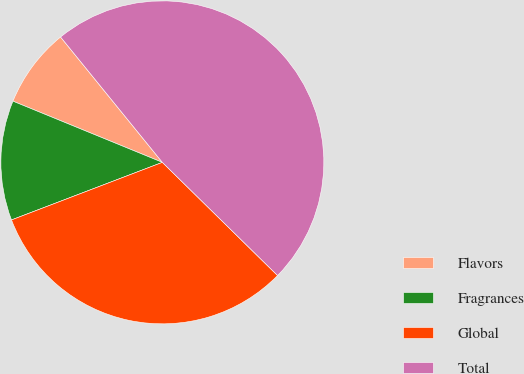Convert chart. <chart><loc_0><loc_0><loc_500><loc_500><pie_chart><fcel>Flavors<fcel>Fragrances<fcel>Global<fcel>Total<nl><fcel>7.96%<fcel>11.99%<fcel>31.84%<fcel>48.21%<nl></chart> 